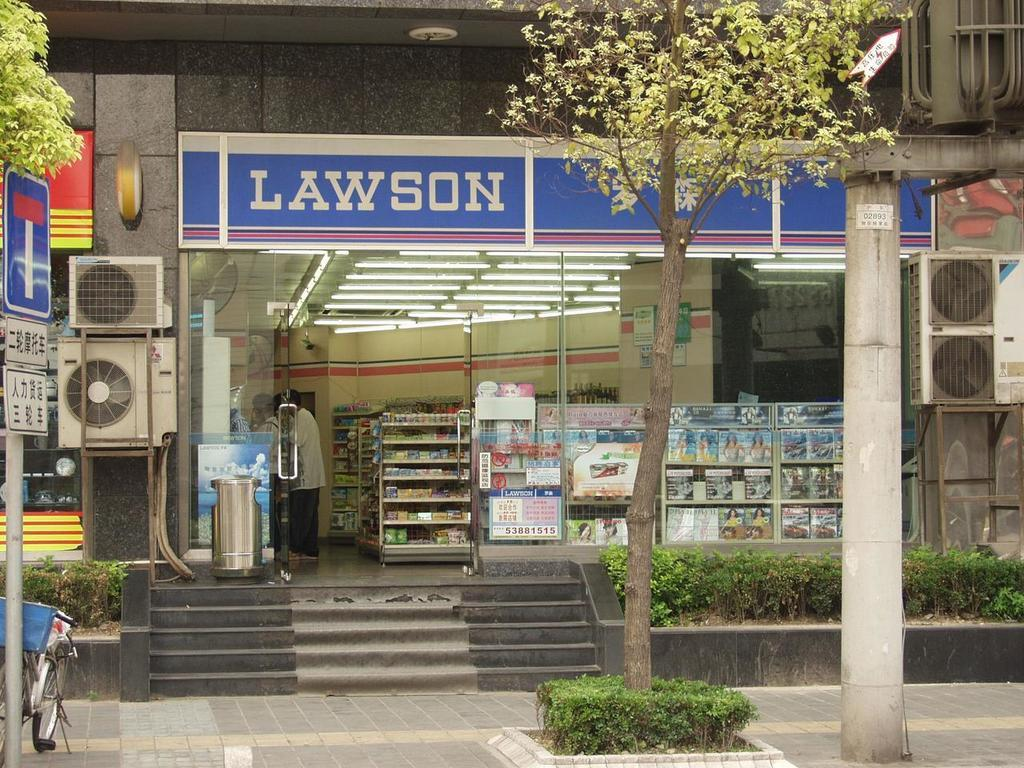<image>
Write a terse but informative summary of the picture. A store has a white and blue sign that shows it is called Lawson. 